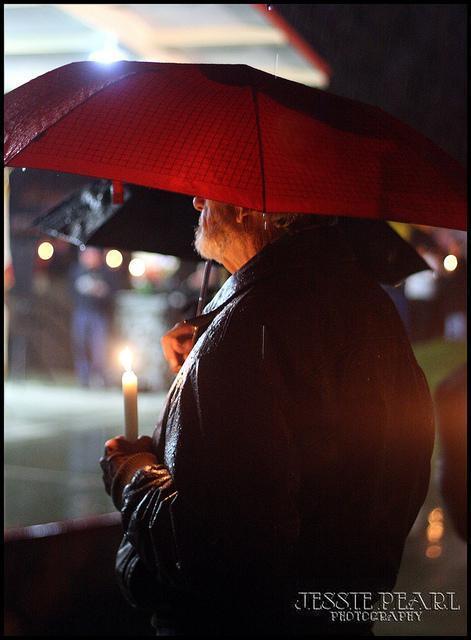How many people can be seen?
Give a very brief answer. 1. How many umbrellas are there?
Give a very brief answer. 2. How many elephants are facing toward the camera?
Give a very brief answer. 0. 